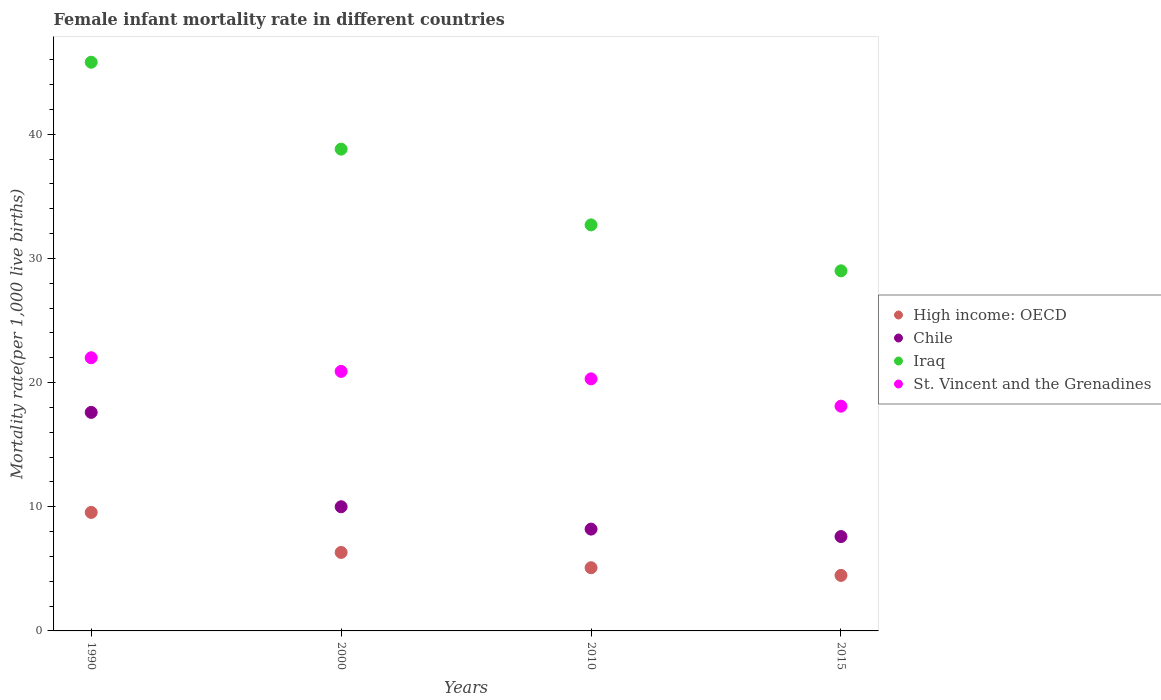Is the number of dotlines equal to the number of legend labels?
Your answer should be compact. Yes. Across all years, what is the maximum female infant mortality rate in High income: OECD?
Keep it short and to the point. 9.54. In which year was the female infant mortality rate in High income: OECD minimum?
Offer a terse response. 2015. What is the total female infant mortality rate in Chile in the graph?
Provide a short and direct response. 43.4. What is the difference between the female infant mortality rate in St. Vincent and the Grenadines in 1990 and that in 2000?
Your answer should be very brief. 1.1. What is the difference between the female infant mortality rate in Chile in 2015 and the female infant mortality rate in St. Vincent and the Grenadines in 2000?
Give a very brief answer. -13.3. What is the average female infant mortality rate in Chile per year?
Offer a terse response. 10.85. In the year 1990, what is the difference between the female infant mortality rate in St. Vincent and the Grenadines and female infant mortality rate in Chile?
Make the answer very short. 4.4. What is the ratio of the female infant mortality rate in High income: OECD in 2000 to that in 2010?
Provide a succinct answer. 1.24. Is the female infant mortality rate in High income: OECD in 2000 less than that in 2010?
Offer a terse response. No. Is the difference between the female infant mortality rate in St. Vincent and the Grenadines in 2010 and 2015 greater than the difference between the female infant mortality rate in Chile in 2010 and 2015?
Your response must be concise. Yes. What is the difference between the highest and the second highest female infant mortality rate in High income: OECD?
Your response must be concise. 3.22. What is the difference between the highest and the lowest female infant mortality rate in Chile?
Your answer should be compact. 10. Is it the case that in every year, the sum of the female infant mortality rate in Iraq and female infant mortality rate in Chile  is greater than the female infant mortality rate in High income: OECD?
Give a very brief answer. Yes. Does the female infant mortality rate in St. Vincent and the Grenadines monotonically increase over the years?
Make the answer very short. No. How many dotlines are there?
Provide a short and direct response. 4. How many years are there in the graph?
Keep it short and to the point. 4. Does the graph contain grids?
Keep it short and to the point. No. How are the legend labels stacked?
Provide a succinct answer. Vertical. What is the title of the graph?
Ensure brevity in your answer.  Female infant mortality rate in different countries. What is the label or title of the Y-axis?
Keep it short and to the point. Mortality rate(per 1,0 live births). What is the Mortality rate(per 1,000 live births) in High income: OECD in 1990?
Your answer should be very brief. 9.54. What is the Mortality rate(per 1,000 live births) of Chile in 1990?
Ensure brevity in your answer.  17.6. What is the Mortality rate(per 1,000 live births) in Iraq in 1990?
Give a very brief answer. 45.8. What is the Mortality rate(per 1,000 live births) in High income: OECD in 2000?
Keep it short and to the point. 6.32. What is the Mortality rate(per 1,000 live births) of Iraq in 2000?
Offer a very short reply. 38.8. What is the Mortality rate(per 1,000 live births) of St. Vincent and the Grenadines in 2000?
Your response must be concise. 20.9. What is the Mortality rate(per 1,000 live births) in High income: OECD in 2010?
Provide a short and direct response. 5.09. What is the Mortality rate(per 1,000 live births) in Chile in 2010?
Provide a succinct answer. 8.2. What is the Mortality rate(per 1,000 live births) of Iraq in 2010?
Give a very brief answer. 32.7. What is the Mortality rate(per 1,000 live births) in St. Vincent and the Grenadines in 2010?
Provide a short and direct response. 20.3. What is the Mortality rate(per 1,000 live births) in High income: OECD in 2015?
Give a very brief answer. 4.47. What is the Mortality rate(per 1,000 live births) in Chile in 2015?
Your answer should be compact. 7.6. What is the Mortality rate(per 1,000 live births) of St. Vincent and the Grenadines in 2015?
Make the answer very short. 18.1. Across all years, what is the maximum Mortality rate(per 1,000 live births) in High income: OECD?
Keep it short and to the point. 9.54. Across all years, what is the maximum Mortality rate(per 1,000 live births) of Chile?
Your answer should be very brief. 17.6. Across all years, what is the maximum Mortality rate(per 1,000 live births) in Iraq?
Your answer should be compact. 45.8. Across all years, what is the minimum Mortality rate(per 1,000 live births) in High income: OECD?
Offer a terse response. 4.47. Across all years, what is the minimum Mortality rate(per 1,000 live births) of Chile?
Offer a terse response. 7.6. Across all years, what is the minimum Mortality rate(per 1,000 live births) in Iraq?
Offer a terse response. 29. Across all years, what is the minimum Mortality rate(per 1,000 live births) in St. Vincent and the Grenadines?
Offer a very short reply. 18.1. What is the total Mortality rate(per 1,000 live births) in High income: OECD in the graph?
Offer a terse response. 25.42. What is the total Mortality rate(per 1,000 live births) in Chile in the graph?
Your response must be concise. 43.4. What is the total Mortality rate(per 1,000 live births) of Iraq in the graph?
Provide a succinct answer. 146.3. What is the total Mortality rate(per 1,000 live births) in St. Vincent and the Grenadines in the graph?
Keep it short and to the point. 81.3. What is the difference between the Mortality rate(per 1,000 live births) of High income: OECD in 1990 and that in 2000?
Your answer should be very brief. 3.22. What is the difference between the Mortality rate(per 1,000 live births) in Chile in 1990 and that in 2000?
Offer a very short reply. 7.6. What is the difference between the Mortality rate(per 1,000 live births) of Iraq in 1990 and that in 2000?
Offer a very short reply. 7. What is the difference between the Mortality rate(per 1,000 live births) in St. Vincent and the Grenadines in 1990 and that in 2000?
Your response must be concise. 1.1. What is the difference between the Mortality rate(per 1,000 live births) of High income: OECD in 1990 and that in 2010?
Your answer should be very brief. 4.45. What is the difference between the Mortality rate(per 1,000 live births) in Chile in 1990 and that in 2010?
Provide a succinct answer. 9.4. What is the difference between the Mortality rate(per 1,000 live births) of Iraq in 1990 and that in 2010?
Your answer should be very brief. 13.1. What is the difference between the Mortality rate(per 1,000 live births) of St. Vincent and the Grenadines in 1990 and that in 2010?
Your response must be concise. 1.7. What is the difference between the Mortality rate(per 1,000 live births) in High income: OECD in 1990 and that in 2015?
Your answer should be very brief. 5.07. What is the difference between the Mortality rate(per 1,000 live births) in Chile in 1990 and that in 2015?
Keep it short and to the point. 10. What is the difference between the Mortality rate(per 1,000 live births) of High income: OECD in 2000 and that in 2010?
Your response must be concise. 1.23. What is the difference between the Mortality rate(per 1,000 live births) in Chile in 2000 and that in 2010?
Your answer should be very brief. 1.8. What is the difference between the Mortality rate(per 1,000 live births) of St. Vincent and the Grenadines in 2000 and that in 2010?
Provide a short and direct response. 0.6. What is the difference between the Mortality rate(per 1,000 live births) in High income: OECD in 2000 and that in 2015?
Your response must be concise. 1.85. What is the difference between the Mortality rate(per 1,000 live births) in Iraq in 2000 and that in 2015?
Ensure brevity in your answer.  9.8. What is the difference between the Mortality rate(per 1,000 live births) in High income: OECD in 2010 and that in 2015?
Provide a succinct answer. 0.62. What is the difference between the Mortality rate(per 1,000 live births) of Chile in 2010 and that in 2015?
Keep it short and to the point. 0.6. What is the difference between the Mortality rate(per 1,000 live births) of Iraq in 2010 and that in 2015?
Your answer should be very brief. 3.7. What is the difference between the Mortality rate(per 1,000 live births) of St. Vincent and the Grenadines in 2010 and that in 2015?
Your answer should be compact. 2.2. What is the difference between the Mortality rate(per 1,000 live births) of High income: OECD in 1990 and the Mortality rate(per 1,000 live births) of Chile in 2000?
Provide a succinct answer. -0.46. What is the difference between the Mortality rate(per 1,000 live births) in High income: OECD in 1990 and the Mortality rate(per 1,000 live births) in Iraq in 2000?
Offer a terse response. -29.26. What is the difference between the Mortality rate(per 1,000 live births) in High income: OECD in 1990 and the Mortality rate(per 1,000 live births) in St. Vincent and the Grenadines in 2000?
Give a very brief answer. -11.36. What is the difference between the Mortality rate(per 1,000 live births) of Chile in 1990 and the Mortality rate(per 1,000 live births) of Iraq in 2000?
Ensure brevity in your answer.  -21.2. What is the difference between the Mortality rate(per 1,000 live births) of Iraq in 1990 and the Mortality rate(per 1,000 live births) of St. Vincent and the Grenadines in 2000?
Provide a short and direct response. 24.9. What is the difference between the Mortality rate(per 1,000 live births) in High income: OECD in 1990 and the Mortality rate(per 1,000 live births) in Chile in 2010?
Keep it short and to the point. 1.34. What is the difference between the Mortality rate(per 1,000 live births) in High income: OECD in 1990 and the Mortality rate(per 1,000 live births) in Iraq in 2010?
Your answer should be compact. -23.16. What is the difference between the Mortality rate(per 1,000 live births) of High income: OECD in 1990 and the Mortality rate(per 1,000 live births) of St. Vincent and the Grenadines in 2010?
Offer a very short reply. -10.76. What is the difference between the Mortality rate(per 1,000 live births) of Chile in 1990 and the Mortality rate(per 1,000 live births) of Iraq in 2010?
Your answer should be very brief. -15.1. What is the difference between the Mortality rate(per 1,000 live births) in High income: OECD in 1990 and the Mortality rate(per 1,000 live births) in Chile in 2015?
Your response must be concise. 1.94. What is the difference between the Mortality rate(per 1,000 live births) in High income: OECD in 1990 and the Mortality rate(per 1,000 live births) in Iraq in 2015?
Your answer should be compact. -19.46. What is the difference between the Mortality rate(per 1,000 live births) in High income: OECD in 1990 and the Mortality rate(per 1,000 live births) in St. Vincent and the Grenadines in 2015?
Ensure brevity in your answer.  -8.56. What is the difference between the Mortality rate(per 1,000 live births) of Chile in 1990 and the Mortality rate(per 1,000 live births) of Iraq in 2015?
Offer a very short reply. -11.4. What is the difference between the Mortality rate(per 1,000 live births) of Chile in 1990 and the Mortality rate(per 1,000 live births) of St. Vincent and the Grenadines in 2015?
Ensure brevity in your answer.  -0.5. What is the difference between the Mortality rate(per 1,000 live births) in Iraq in 1990 and the Mortality rate(per 1,000 live births) in St. Vincent and the Grenadines in 2015?
Offer a very short reply. 27.7. What is the difference between the Mortality rate(per 1,000 live births) of High income: OECD in 2000 and the Mortality rate(per 1,000 live births) of Chile in 2010?
Your answer should be compact. -1.88. What is the difference between the Mortality rate(per 1,000 live births) in High income: OECD in 2000 and the Mortality rate(per 1,000 live births) in Iraq in 2010?
Offer a very short reply. -26.38. What is the difference between the Mortality rate(per 1,000 live births) in High income: OECD in 2000 and the Mortality rate(per 1,000 live births) in St. Vincent and the Grenadines in 2010?
Give a very brief answer. -13.98. What is the difference between the Mortality rate(per 1,000 live births) in Chile in 2000 and the Mortality rate(per 1,000 live births) in Iraq in 2010?
Offer a terse response. -22.7. What is the difference between the Mortality rate(per 1,000 live births) in Iraq in 2000 and the Mortality rate(per 1,000 live births) in St. Vincent and the Grenadines in 2010?
Ensure brevity in your answer.  18.5. What is the difference between the Mortality rate(per 1,000 live births) of High income: OECD in 2000 and the Mortality rate(per 1,000 live births) of Chile in 2015?
Your answer should be compact. -1.28. What is the difference between the Mortality rate(per 1,000 live births) of High income: OECD in 2000 and the Mortality rate(per 1,000 live births) of Iraq in 2015?
Ensure brevity in your answer.  -22.68. What is the difference between the Mortality rate(per 1,000 live births) of High income: OECD in 2000 and the Mortality rate(per 1,000 live births) of St. Vincent and the Grenadines in 2015?
Provide a short and direct response. -11.78. What is the difference between the Mortality rate(per 1,000 live births) in Iraq in 2000 and the Mortality rate(per 1,000 live births) in St. Vincent and the Grenadines in 2015?
Your answer should be very brief. 20.7. What is the difference between the Mortality rate(per 1,000 live births) of High income: OECD in 2010 and the Mortality rate(per 1,000 live births) of Chile in 2015?
Keep it short and to the point. -2.51. What is the difference between the Mortality rate(per 1,000 live births) of High income: OECD in 2010 and the Mortality rate(per 1,000 live births) of Iraq in 2015?
Ensure brevity in your answer.  -23.91. What is the difference between the Mortality rate(per 1,000 live births) of High income: OECD in 2010 and the Mortality rate(per 1,000 live births) of St. Vincent and the Grenadines in 2015?
Offer a terse response. -13.01. What is the difference between the Mortality rate(per 1,000 live births) in Chile in 2010 and the Mortality rate(per 1,000 live births) in Iraq in 2015?
Offer a terse response. -20.8. What is the difference between the Mortality rate(per 1,000 live births) of Chile in 2010 and the Mortality rate(per 1,000 live births) of St. Vincent and the Grenadines in 2015?
Provide a succinct answer. -9.9. What is the average Mortality rate(per 1,000 live births) in High income: OECD per year?
Your response must be concise. 6.36. What is the average Mortality rate(per 1,000 live births) in Chile per year?
Keep it short and to the point. 10.85. What is the average Mortality rate(per 1,000 live births) of Iraq per year?
Offer a very short reply. 36.58. What is the average Mortality rate(per 1,000 live births) of St. Vincent and the Grenadines per year?
Provide a short and direct response. 20.32. In the year 1990, what is the difference between the Mortality rate(per 1,000 live births) of High income: OECD and Mortality rate(per 1,000 live births) of Chile?
Your answer should be very brief. -8.06. In the year 1990, what is the difference between the Mortality rate(per 1,000 live births) in High income: OECD and Mortality rate(per 1,000 live births) in Iraq?
Your answer should be very brief. -36.26. In the year 1990, what is the difference between the Mortality rate(per 1,000 live births) of High income: OECD and Mortality rate(per 1,000 live births) of St. Vincent and the Grenadines?
Provide a succinct answer. -12.46. In the year 1990, what is the difference between the Mortality rate(per 1,000 live births) in Chile and Mortality rate(per 1,000 live births) in Iraq?
Provide a short and direct response. -28.2. In the year 1990, what is the difference between the Mortality rate(per 1,000 live births) in Iraq and Mortality rate(per 1,000 live births) in St. Vincent and the Grenadines?
Offer a very short reply. 23.8. In the year 2000, what is the difference between the Mortality rate(per 1,000 live births) of High income: OECD and Mortality rate(per 1,000 live births) of Chile?
Give a very brief answer. -3.68. In the year 2000, what is the difference between the Mortality rate(per 1,000 live births) in High income: OECD and Mortality rate(per 1,000 live births) in Iraq?
Provide a short and direct response. -32.48. In the year 2000, what is the difference between the Mortality rate(per 1,000 live births) of High income: OECD and Mortality rate(per 1,000 live births) of St. Vincent and the Grenadines?
Provide a succinct answer. -14.58. In the year 2000, what is the difference between the Mortality rate(per 1,000 live births) of Chile and Mortality rate(per 1,000 live births) of Iraq?
Provide a short and direct response. -28.8. In the year 2010, what is the difference between the Mortality rate(per 1,000 live births) of High income: OECD and Mortality rate(per 1,000 live births) of Chile?
Offer a terse response. -3.11. In the year 2010, what is the difference between the Mortality rate(per 1,000 live births) in High income: OECD and Mortality rate(per 1,000 live births) in Iraq?
Give a very brief answer. -27.61. In the year 2010, what is the difference between the Mortality rate(per 1,000 live births) of High income: OECD and Mortality rate(per 1,000 live births) of St. Vincent and the Grenadines?
Make the answer very short. -15.21. In the year 2010, what is the difference between the Mortality rate(per 1,000 live births) in Chile and Mortality rate(per 1,000 live births) in Iraq?
Provide a short and direct response. -24.5. In the year 2010, what is the difference between the Mortality rate(per 1,000 live births) in Chile and Mortality rate(per 1,000 live births) in St. Vincent and the Grenadines?
Provide a succinct answer. -12.1. In the year 2015, what is the difference between the Mortality rate(per 1,000 live births) in High income: OECD and Mortality rate(per 1,000 live births) in Chile?
Keep it short and to the point. -3.13. In the year 2015, what is the difference between the Mortality rate(per 1,000 live births) of High income: OECD and Mortality rate(per 1,000 live births) of Iraq?
Provide a short and direct response. -24.53. In the year 2015, what is the difference between the Mortality rate(per 1,000 live births) in High income: OECD and Mortality rate(per 1,000 live births) in St. Vincent and the Grenadines?
Offer a very short reply. -13.63. In the year 2015, what is the difference between the Mortality rate(per 1,000 live births) of Chile and Mortality rate(per 1,000 live births) of Iraq?
Offer a very short reply. -21.4. In the year 2015, what is the difference between the Mortality rate(per 1,000 live births) in Chile and Mortality rate(per 1,000 live births) in St. Vincent and the Grenadines?
Your response must be concise. -10.5. In the year 2015, what is the difference between the Mortality rate(per 1,000 live births) in Iraq and Mortality rate(per 1,000 live births) in St. Vincent and the Grenadines?
Your response must be concise. 10.9. What is the ratio of the Mortality rate(per 1,000 live births) of High income: OECD in 1990 to that in 2000?
Make the answer very short. 1.51. What is the ratio of the Mortality rate(per 1,000 live births) in Chile in 1990 to that in 2000?
Keep it short and to the point. 1.76. What is the ratio of the Mortality rate(per 1,000 live births) of Iraq in 1990 to that in 2000?
Ensure brevity in your answer.  1.18. What is the ratio of the Mortality rate(per 1,000 live births) of St. Vincent and the Grenadines in 1990 to that in 2000?
Provide a short and direct response. 1.05. What is the ratio of the Mortality rate(per 1,000 live births) of High income: OECD in 1990 to that in 2010?
Your response must be concise. 1.88. What is the ratio of the Mortality rate(per 1,000 live births) of Chile in 1990 to that in 2010?
Your answer should be very brief. 2.15. What is the ratio of the Mortality rate(per 1,000 live births) of Iraq in 1990 to that in 2010?
Provide a succinct answer. 1.4. What is the ratio of the Mortality rate(per 1,000 live births) in St. Vincent and the Grenadines in 1990 to that in 2010?
Provide a succinct answer. 1.08. What is the ratio of the Mortality rate(per 1,000 live births) in High income: OECD in 1990 to that in 2015?
Provide a succinct answer. 2.13. What is the ratio of the Mortality rate(per 1,000 live births) in Chile in 1990 to that in 2015?
Make the answer very short. 2.32. What is the ratio of the Mortality rate(per 1,000 live births) in Iraq in 1990 to that in 2015?
Your response must be concise. 1.58. What is the ratio of the Mortality rate(per 1,000 live births) in St. Vincent and the Grenadines in 1990 to that in 2015?
Keep it short and to the point. 1.22. What is the ratio of the Mortality rate(per 1,000 live births) in High income: OECD in 2000 to that in 2010?
Your response must be concise. 1.24. What is the ratio of the Mortality rate(per 1,000 live births) in Chile in 2000 to that in 2010?
Keep it short and to the point. 1.22. What is the ratio of the Mortality rate(per 1,000 live births) of Iraq in 2000 to that in 2010?
Make the answer very short. 1.19. What is the ratio of the Mortality rate(per 1,000 live births) in St. Vincent and the Grenadines in 2000 to that in 2010?
Your answer should be compact. 1.03. What is the ratio of the Mortality rate(per 1,000 live births) of High income: OECD in 2000 to that in 2015?
Provide a succinct answer. 1.41. What is the ratio of the Mortality rate(per 1,000 live births) in Chile in 2000 to that in 2015?
Your response must be concise. 1.32. What is the ratio of the Mortality rate(per 1,000 live births) of Iraq in 2000 to that in 2015?
Your response must be concise. 1.34. What is the ratio of the Mortality rate(per 1,000 live births) in St. Vincent and the Grenadines in 2000 to that in 2015?
Provide a succinct answer. 1.15. What is the ratio of the Mortality rate(per 1,000 live births) of High income: OECD in 2010 to that in 2015?
Your response must be concise. 1.14. What is the ratio of the Mortality rate(per 1,000 live births) of Chile in 2010 to that in 2015?
Your answer should be very brief. 1.08. What is the ratio of the Mortality rate(per 1,000 live births) in Iraq in 2010 to that in 2015?
Provide a short and direct response. 1.13. What is the ratio of the Mortality rate(per 1,000 live births) of St. Vincent and the Grenadines in 2010 to that in 2015?
Offer a terse response. 1.12. What is the difference between the highest and the second highest Mortality rate(per 1,000 live births) in High income: OECD?
Your response must be concise. 3.22. What is the difference between the highest and the second highest Mortality rate(per 1,000 live births) of Chile?
Offer a very short reply. 7.6. What is the difference between the highest and the lowest Mortality rate(per 1,000 live births) in High income: OECD?
Your response must be concise. 5.07. What is the difference between the highest and the lowest Mortality rate(per 1,000 live births) in Iraq?
Provide a succinct answer. 16.8. What is the difference between the highest and the lowest Mortality rate(per 1,000 live births) in St. Vincent and the Grenadines?
Your answer should be compact. 3.9. 